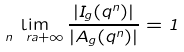<formula> <loc_0><loc_0><loc_500><loc_500>\lim _ { n \ r a + \infty } \frac { | I _ { g } ( q ^ { n } ) | } { | A _ { g } ( q ^ { n } ) | } = 1</formula> 